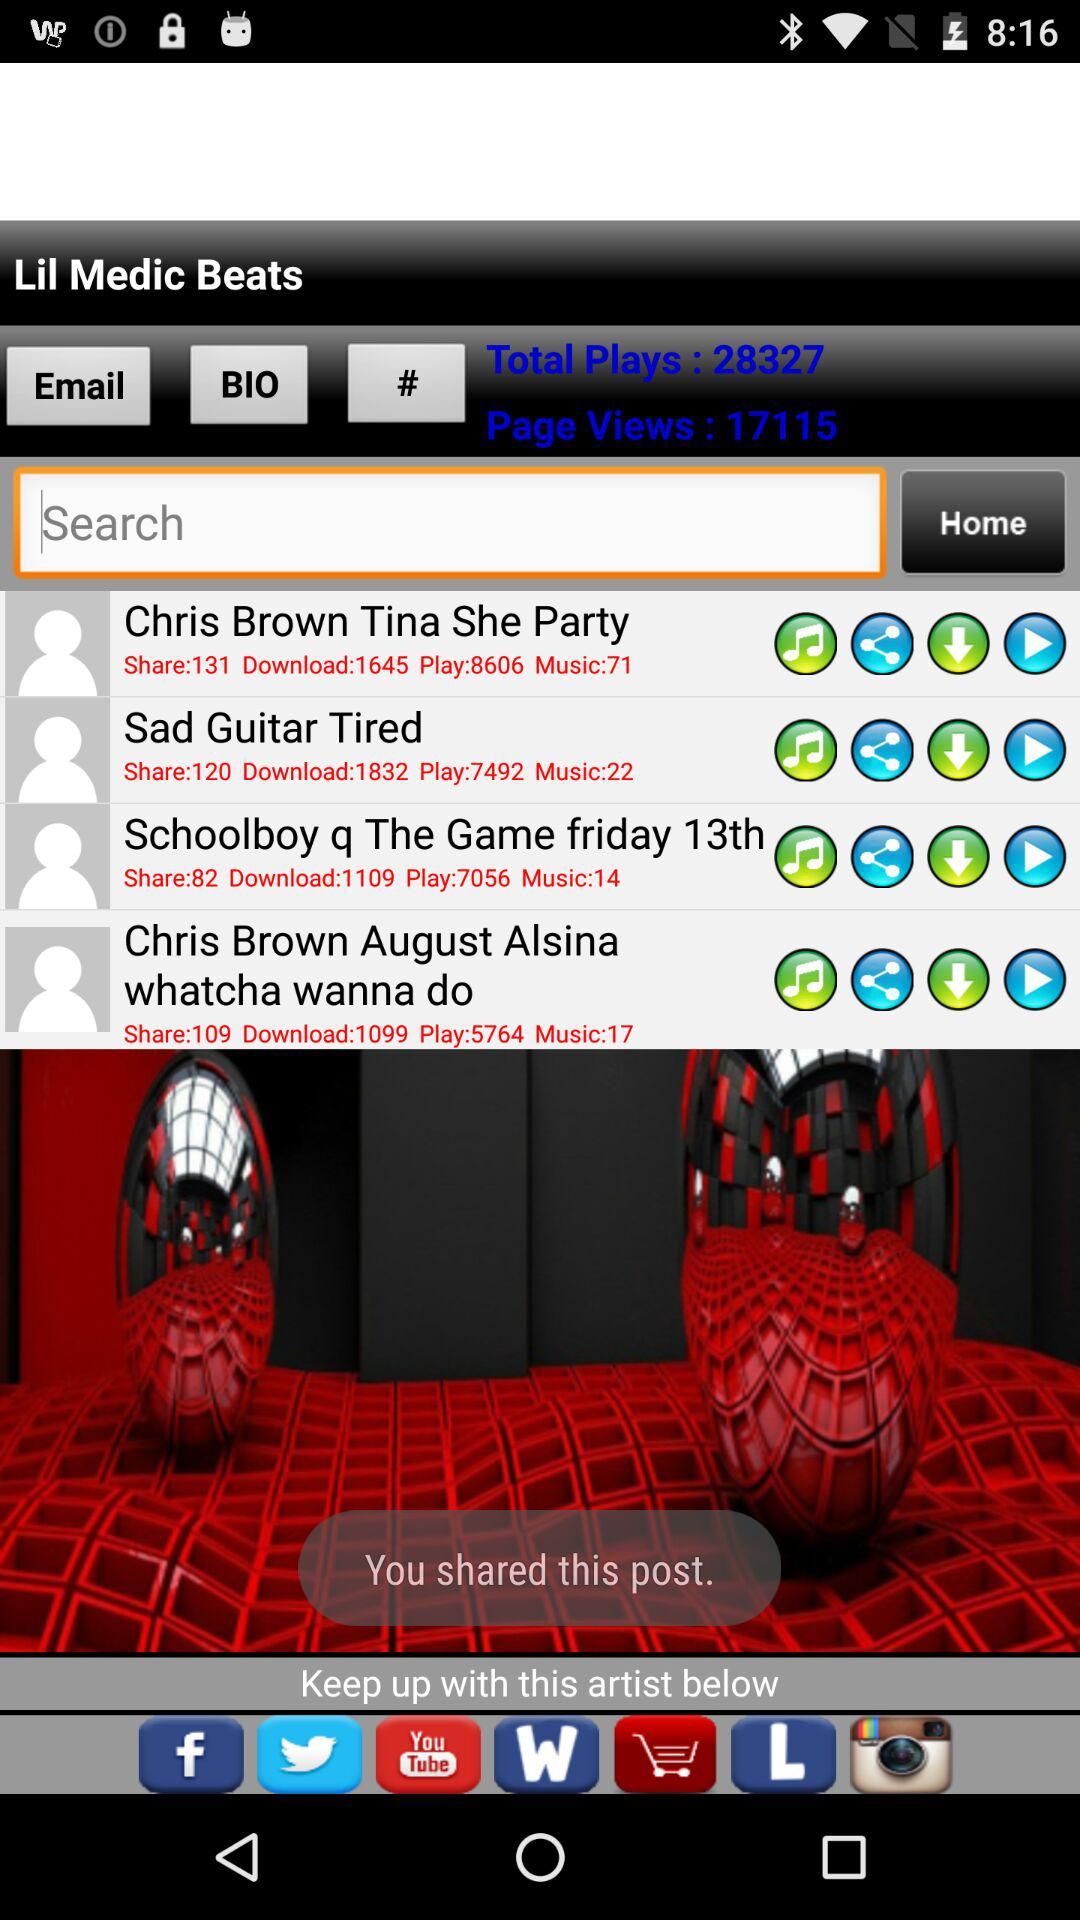What's the music number of "Sad Guitar Tired"? The music number is 22. 